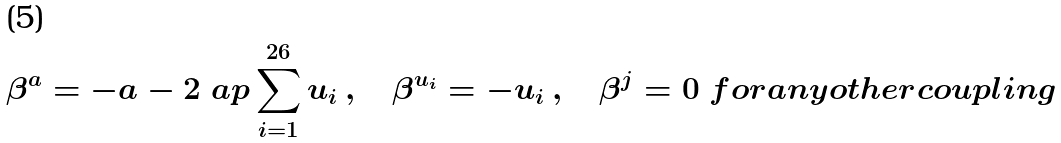<formula> <loc_0><loc_0><loc_500><loc_500>\beta ^ { a } = - a - 2 \ a p \sum _ { i = 1 } ^ { 2 6 } u _ { i } \, , \quad \beta ^ { u _ { i } } = - u _ { i } \, , \quad \beta ^ { j } = 0 \ f o r a n y o t h e r c o u p l i n g</formula> 